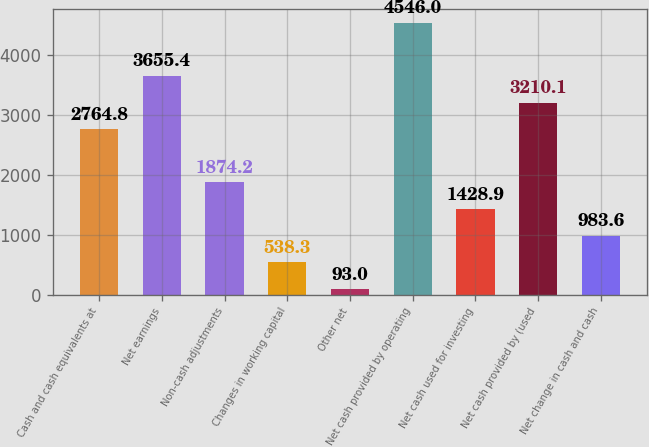Convert chart. <chart><loc_0><loc_0><loc_500><loc_500><bar_chart><fcel>Cash and cash equivalents at<fcel>Net earnings<fcel>Non-cash adjustments<fcel>Changes in working capital<fcel>Other net<fcel>Net cash provided by operating<fcel>Net cash used for investing<fcel>Net cash provided by (used<fcel>Net change in cash and cash<nl><fcel>2764.8<fcel>3655.4<fcel>1874.2<fcel>538.3<fcel>93<fcel>4546<fcel>1428.9<fcel>3210.1<fcel>983.6<nl></chart> 